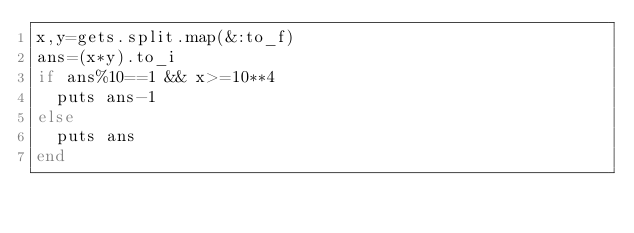<code> <loc_0><loc_0><loc_500><loc_500><_Ruby_>x,y=gets.split.map(&:to_f)
ans=(x*y).to_i
if ans%10==1 && x>=10**4
  puts ans-1
else
  puts ans
end
</code> 